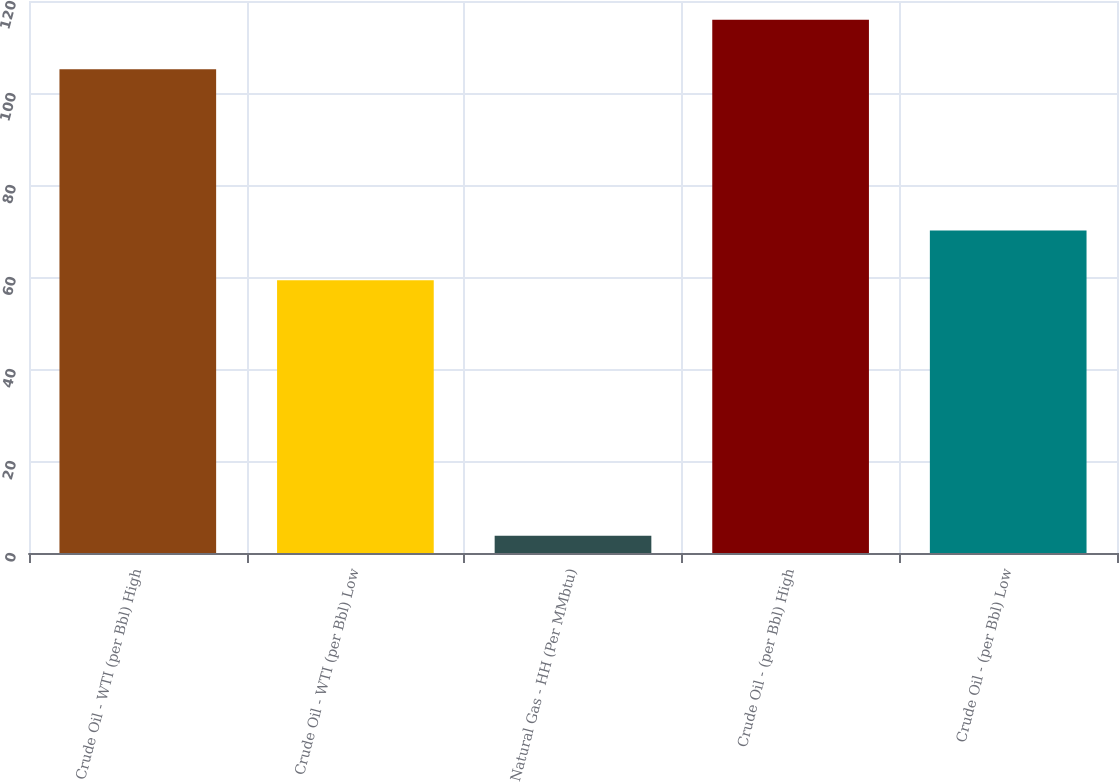Convert chart. <chart><loc_0><loc_0><loc_500><loc_500><bar_chart><fcel>Crude Oil - WTI (per Bbl) High<fcel>Crude Oil - WTI (per Bbl) Low<fcel>Natural Gas - HH (Per MMbtu)<fcel>Crude Oil - (per Bbl) High<fcel>Crude Oil - (per Bbl) Low<nl><fcel>105.15<fcel>59.29<fcel>3.73<fcel>115.95<fcel>70.09<nl></chart> 